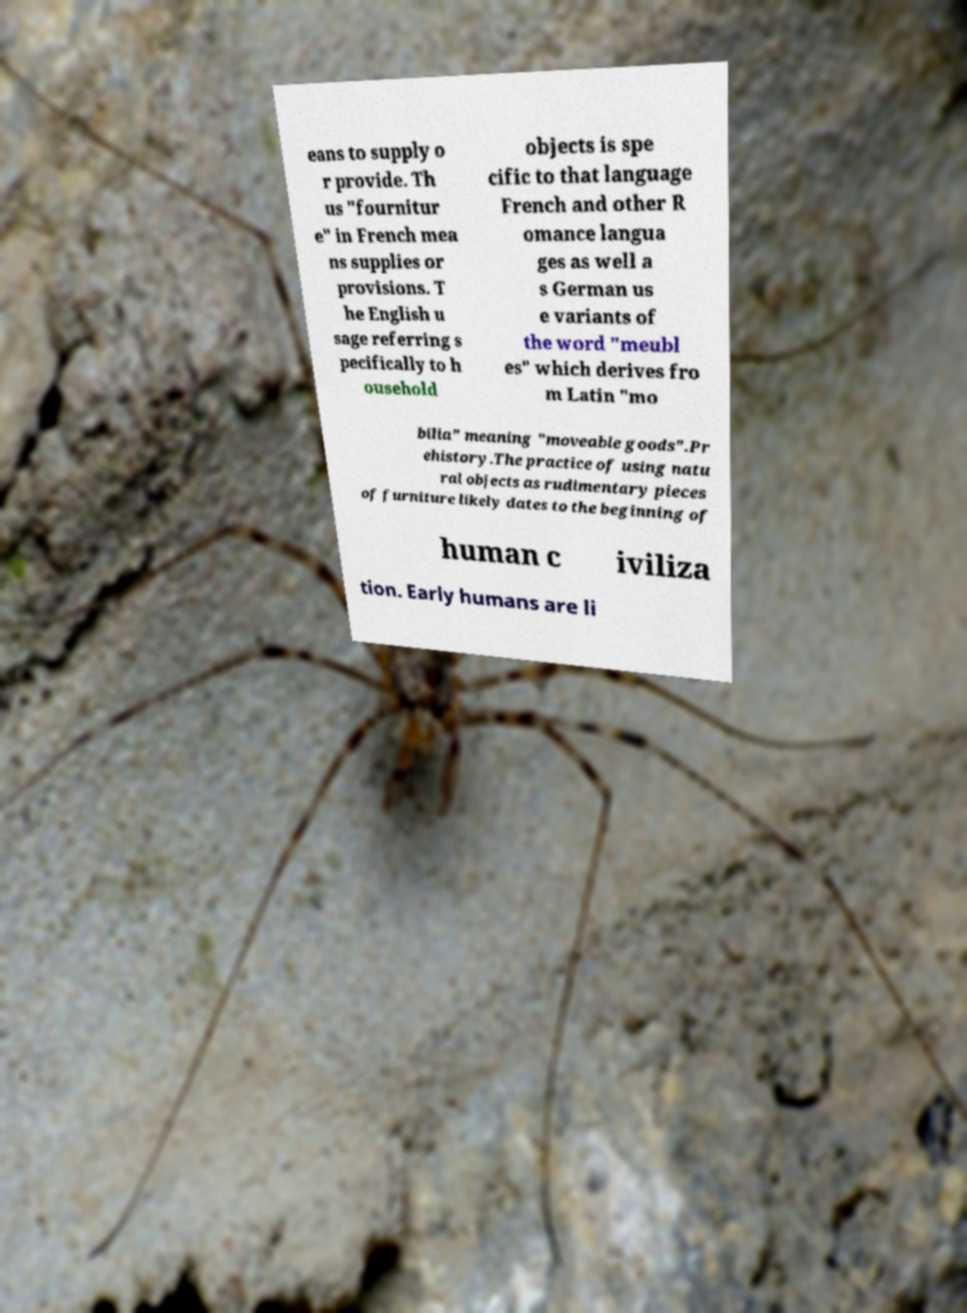Could you assist in decoding the text presented in this image and type it out clearly? eans to supply o r provide. Th us "fournitur e" in French mea ns supplies or provisions. T he English u sage referring s pecifically to h ousehold objects is spe cific to that language French and other R omance langua ges as well a s German us e variants of the word "meubl es" which derives fro m Latin "mo bilia" meaning "moveable goods".Pr ehistory.The practice of using natu ral objects as rudimentary pieces of furniture likely dates to the beginning of human c iviliza tion. Early humans are li 